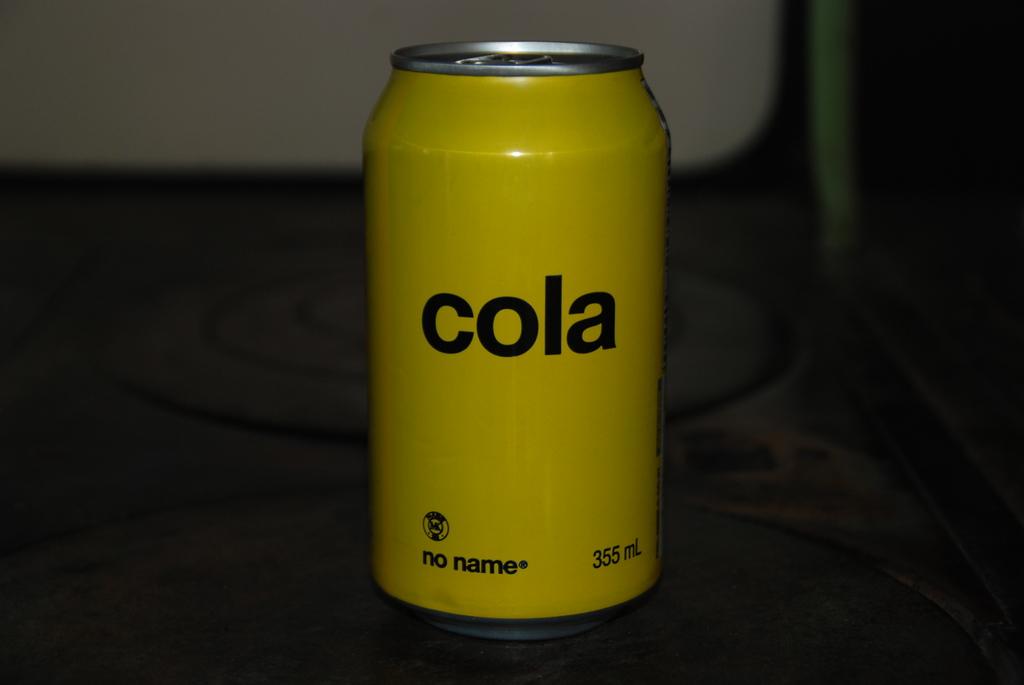The color of the can is?
Ensure brevity in your answer.  Yellow. 